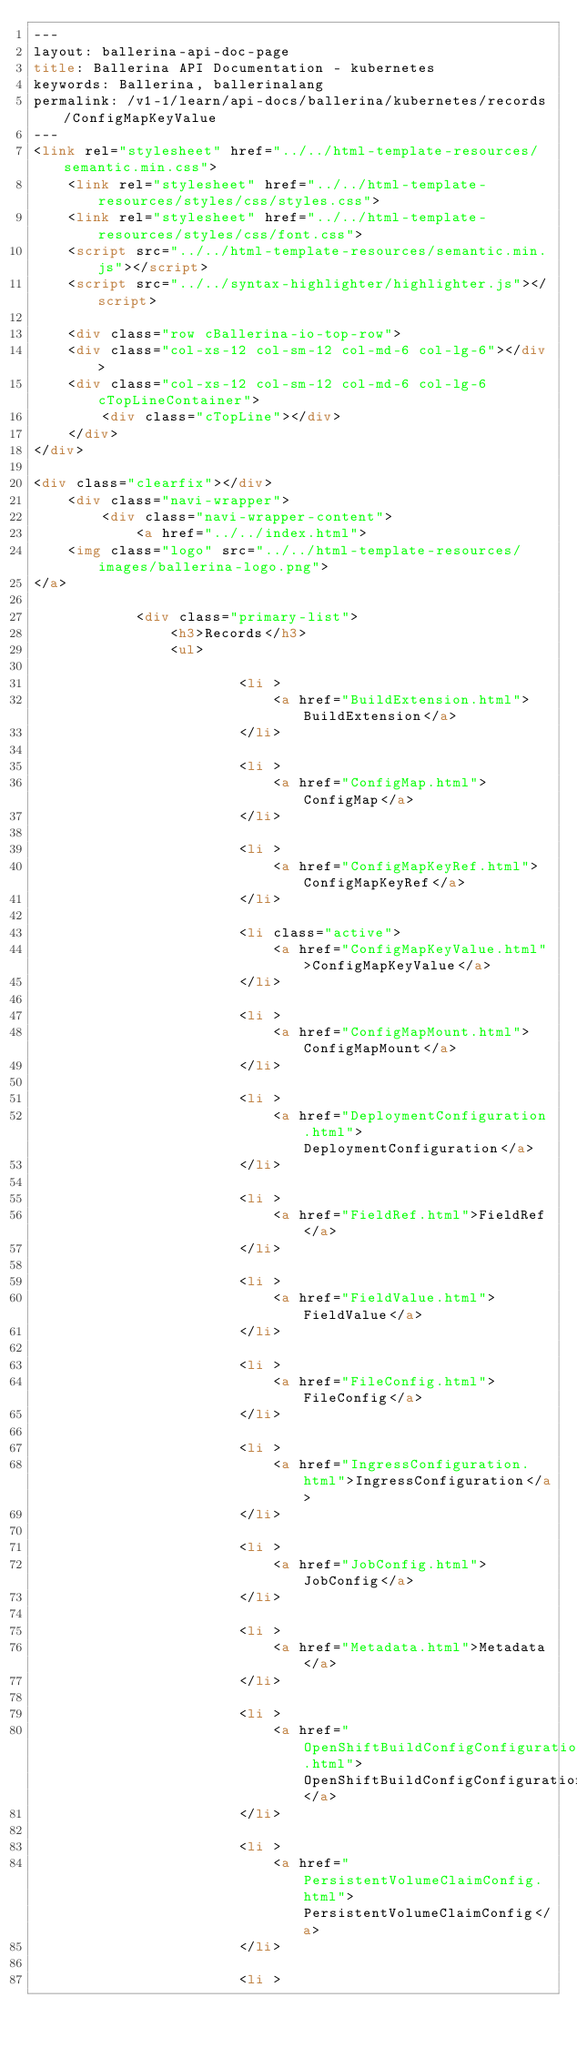<code> <loc_0><loc_0><loc_500><loc_500><_HTML_>---
layout: ballerina-api-doc-page
title: Ballerina API Documentation - kubernetes
keywords: Ballerina, ballerinalang
permalink: /v1-1/learn/api-docs/ballerina/kubernetes/records/ConfigMapKeyValue
---
<link rel="stylesheet" href="../../html-template-resources/semantic.min.css">
    <link rel="stylesheet" href="../../html-template-resources/styles/css/styles.css">
    <link rel="stylesheet" href="../../html-template-resources/styles/css/font.css">
    <script src="../../html-template-resources/semantic.min.js"></script>
    <script src="../../syntax-highlighter/highlighter.js"></script>

    <div class="row cBallerina-io-top-row">
    <div class="col-xs-12 col-sm-12 col-md-6 col-lg-6"></div>
    <div class="col-xs-12 col-sm-12 col-md-6 col-lg-6 cTopLineContainer">
        <div class="cTopLine"></div>
    </div>
</div>

<div class="clearfix"></div>
    <div class="navi-wrapper">
        <div class="navi-wrapper-content">
            <a href="../../index.html">
    <img class="logo" src="../../html-template-resources/images/ballerina-logo.png">
</a>

            <div class="primary-list">
                <h3>Records</h3>
                <ul>
                    
                        <li >
                            <a href="BuildExtension.html">BuildExtension</a>
                        </li>
                    
                        <li >
                            <a href="ConfigMap.html">ConfigMap</a>
                        </li>
                    
                        <li >
                            <a href="ConfigMapKeyRef.html">ConfigMapKeyRef</a>
                        </li>
                    
                        <li class="active">
                            <a href="ConfigMapKeyValue.html">ConfigMapKeyValue</a>
                        </li>
                    
                        <li >
                            <a href="ConfigMapMount.html">ConfigMapMount</a>
                        </li>
                    
                        <li >
                            <a href="DeploymentConfiguration.html">DeploymentConfiguration</a>
                        </li>
                    
                        <li >
                            <a href="FieldRef.html">FieldRef</a>
                        </li>
                    
                        <li >
                            <a href="FieldValue.html">FieldValue</a>
                        </li>
                    
                        <li >
                            <a href="FileConfig.html">FileConfig</a>
                        </li>
                    
                        <li >
                            <a href="IngressConfiguration.html">IngressConfiguration</a>
                        </li>
                    
                        <li >
                            <a href="JobConfig.html">JobConfig</a>
                        </li>
                    
                        <li >
                            <a href="Metadata.html">Metadata</a>
                        </li>
                    
                        <li >
                            <a href="OpenShiftBuildConfigConfiguration.html">OpenShiftBuildConfigConfiguration</a>
                        </li>
                    
                        <li >
                            <a href="PersistentVolumeClaimConfig.html">PersistentVolumeClaimConfig</a>
                        </li>
                    
                        <li ></code> 